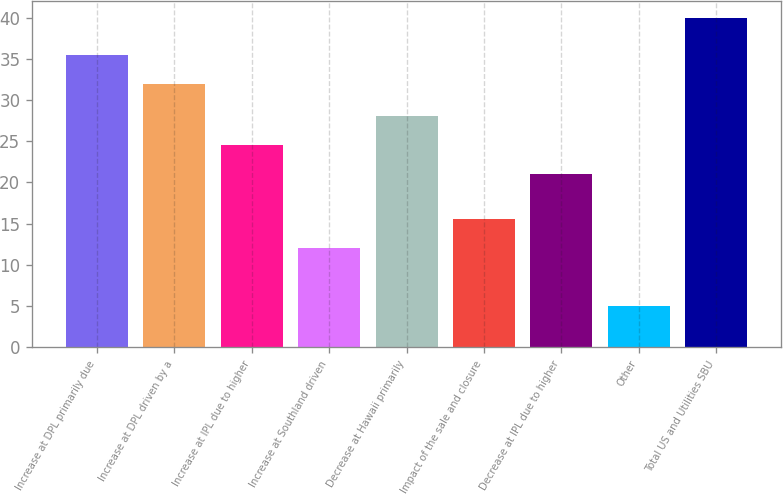Convert chart. <chart><loc_0><loc_0><loc_500><loc_500><bar_chart><fcel>Increase at DPL primarily due<fcel>Increase at DPL driven by a<fcel>Increase at IPL due to higher<fcel>Increase at Southland driven<fcel>Decrease at Hawaii primarily<fcel>Impact of the sale and closure<fcel>Decrease at IPL due to higher<fcel>Other<fcel>Total US and Utilities SBU<nl><fcel>35.5<fcel>32<fcel>24.5<fcel>12<fcel>28<fcel>15.5<fcel>21<fcel>5<fcel>40<nl></chart> 